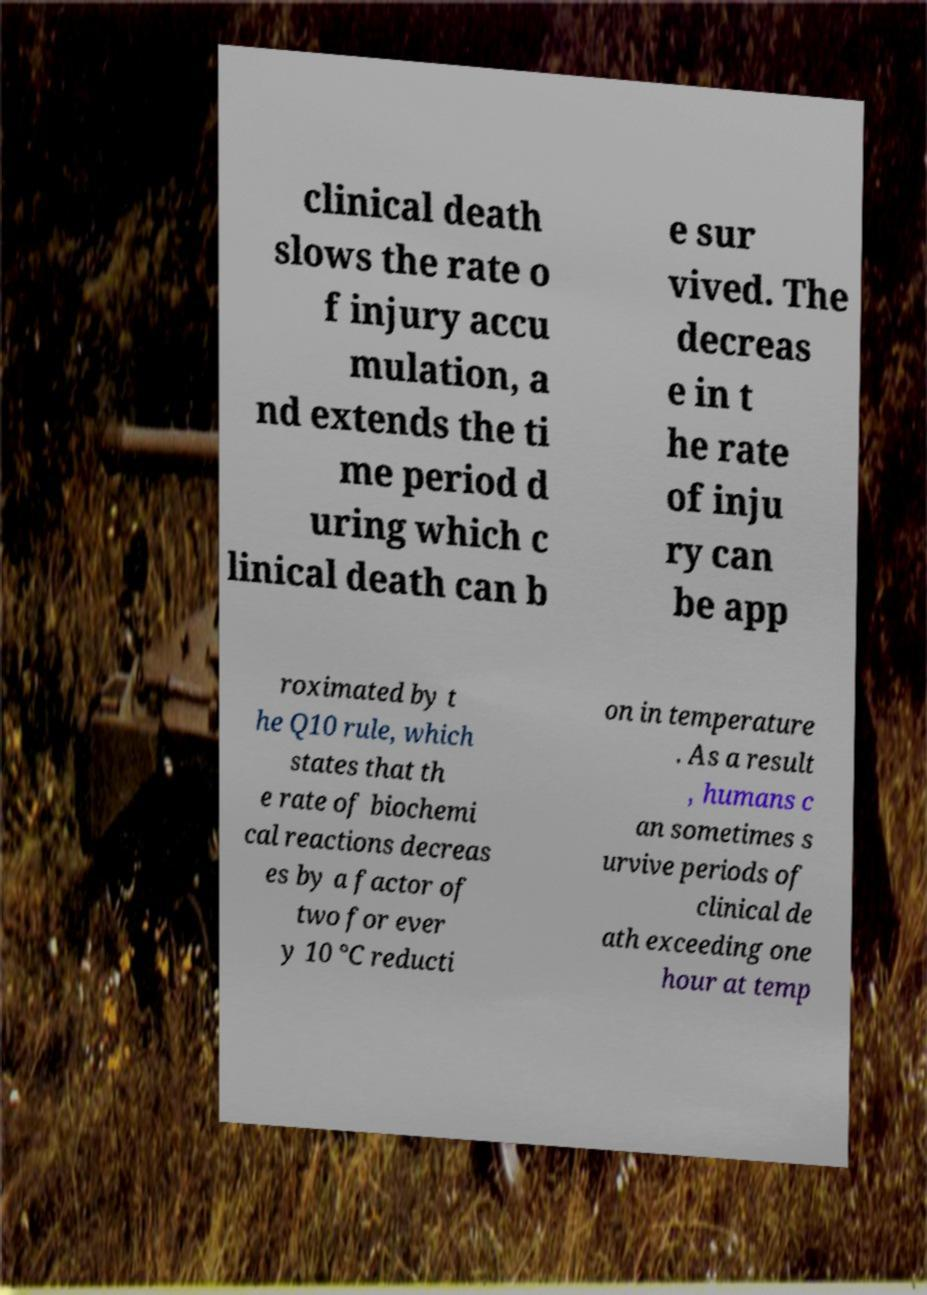Could you extract and type out the text from this image? clinical death slows the rate o f injury accu mulation, a nd extends the ti me period d uring which c linical death can b e sur vived. The decreas e in t he rate of inju ry can be app roximated by t he Q10 rule, which states that th e rate of biochemi cal reactions decreas es by a factor of two for ever y 10 °C reducti on in temperature . As a result , humans c an sometimes s urvive periods of clinical de ath exceeding one hour at temp 